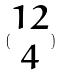Convert formula to latex. <formula><loc_0><loc_0><loc_500><loc_500>( \begin{matrix} 1 2 \\ 4 \end{matrix} )</formula> 